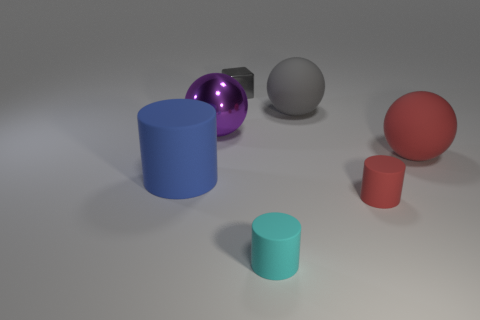Add 3 tiny red things. How many objects exist? 10 Subtract all balls. How many objects are left? 4 Add 7 red cylinders. How many red cylinders are left? 8 Add 2 large red rubber balls. How many large red rubber balls exist? 3 Subtract 1 purple balls. How many objects are left? 6 Subtract all small matte cylinders. Subtract all balls. How many objects are left? 2 